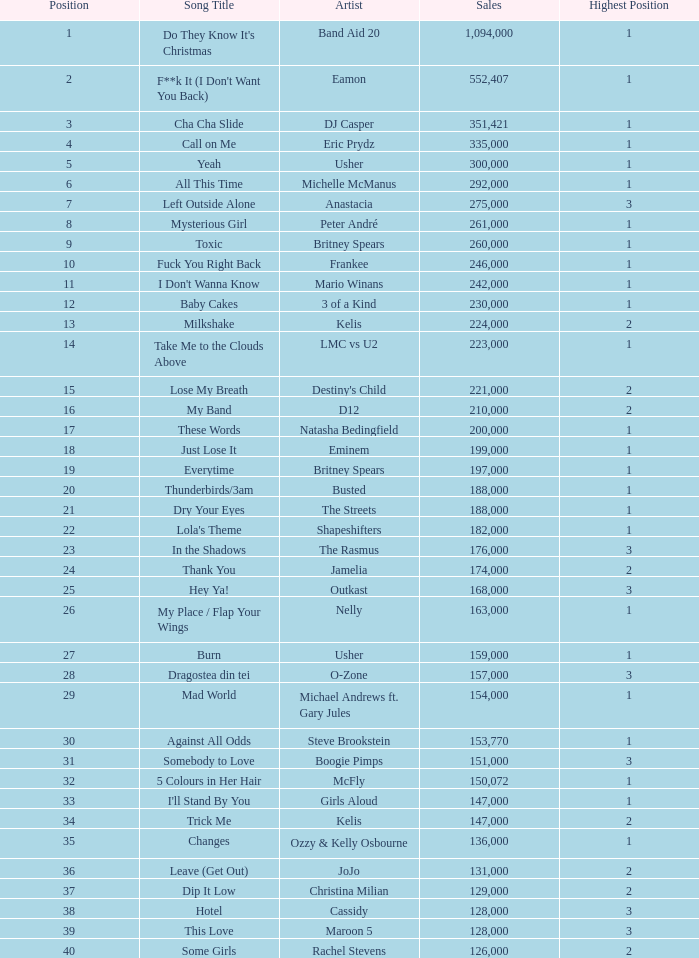Would you be able to parse every entry in this table? {'header': ['Position', 'Song Title', 'Artist', 'Sales', 'Highest Position'], 'rows': [['1', "Do They Know It's Christmas", 'Band Aid 20', '1,094,000', '1'], ['2', "F**k It (I Don't Want You Back)", 'Eamon', '552,407', '1'], ['3', 'Cha Cha Slide', 'DJ Casper', '351,421', '1'], ['4', 'Call on Me', 'Eric Prydz', '335,000', '1'], ['5', 'Yeah', 'Usher', '300,000', '1'], ['6', 'All This Time', 'Michelle McManus', '292,000', '1'], ['7', 'Left Outside Alone', 'Anastacia', '275,000', '3'], ['8', 'Mysterious Girl', 'Peter André', '261,000', '1'], ['9', 'Toxic', 'Britney Spears', '260,000', '1'], ['10', 'Fuck You Right Back', 'Frankee', '246,000', '1'], ['11', "I Don't Wanna Know", 'Mario Winans', '242,000', '1'], ['12', 'Baby Cakes', '3 of a Kind', '230,000', '1'], ['13', 'Milkshake', 'Kelis', '224,000', '2'], ['14', 'Take Me to the Clouds Above', 'LMC vs U2', '223,000', '1'], ['15', 'Lose My Breath', "Destiny's Child", '221,000', '2'], ['16', 'My Band', 'D12', '210,000', '2'], ['17', 'These Words', 'Natasha Bedingfield', '200,000', '1'], ['18', 'Just Lose It', 'Eminem', '199,000', '1'], ['19', 'Everytime', 'Britney Spears', '197,000', '1'], ['20', 'Thunderbirds/3am', 'Busted', '188,000', '1'], ['21', 'Dry Your Eyes', 'The Streets', '188,000', '1'], ['22', "Lola's Theme", 'Shapeshifters', '182,000', '1'], ['23', 'In the Shadows', 'The Rasmus', '176,000', '3'], ['24', 'Thank You', 'Jamelia', '174,000', '2'], ['25', 'Hey Ya!', 'Outkast', '168,000', '3'], ['26', 'My Place / Flap Your Wings', 'Nelly', '163,000', '1'], ['27', 'Burn', 'Usher', '159,000', '1'], ['28', 'Dragostea din tei', 'O-Zone', '157,000', '3'], ['29', 'Mad World', 'Michael Andrews ft. Gary Jules', '154,000', '1'], ['30', 'Against All Odds', 'Steve Brookstein', '153,770', '1'], ['31', 'Somebody to Love', 'Boogie Pimps', '151,000', '3'], ['32', '5 Colours in Her Hair', 'McFly', '150,072', '1'], ['33', "I'll Stand By You", 'Girls Aloud', '147,000', '1'], ['34', 'Trick Me', 'Kelis', '147,000', '2'], ['35', 'Changes', 'Ozzy & Kelly Osbourne', '136,000', '1'], ['36', 'Leave (Get Out)', 'JoJo', '131,000', '2'], ['37', 'Dip It Low', 'Christina Milian', '129,000', '2'], ['38', 'Hotel', 'Cassidy', '128,000', '3'], ['39', 'This Love', 'Maroon 5', '128,000', '3'], ['40', 'Some Girls', 'Rachel Stevens', '126,000', '2']]} What were the revenues for dj casper when he was ranked below 13? 351421.0. 